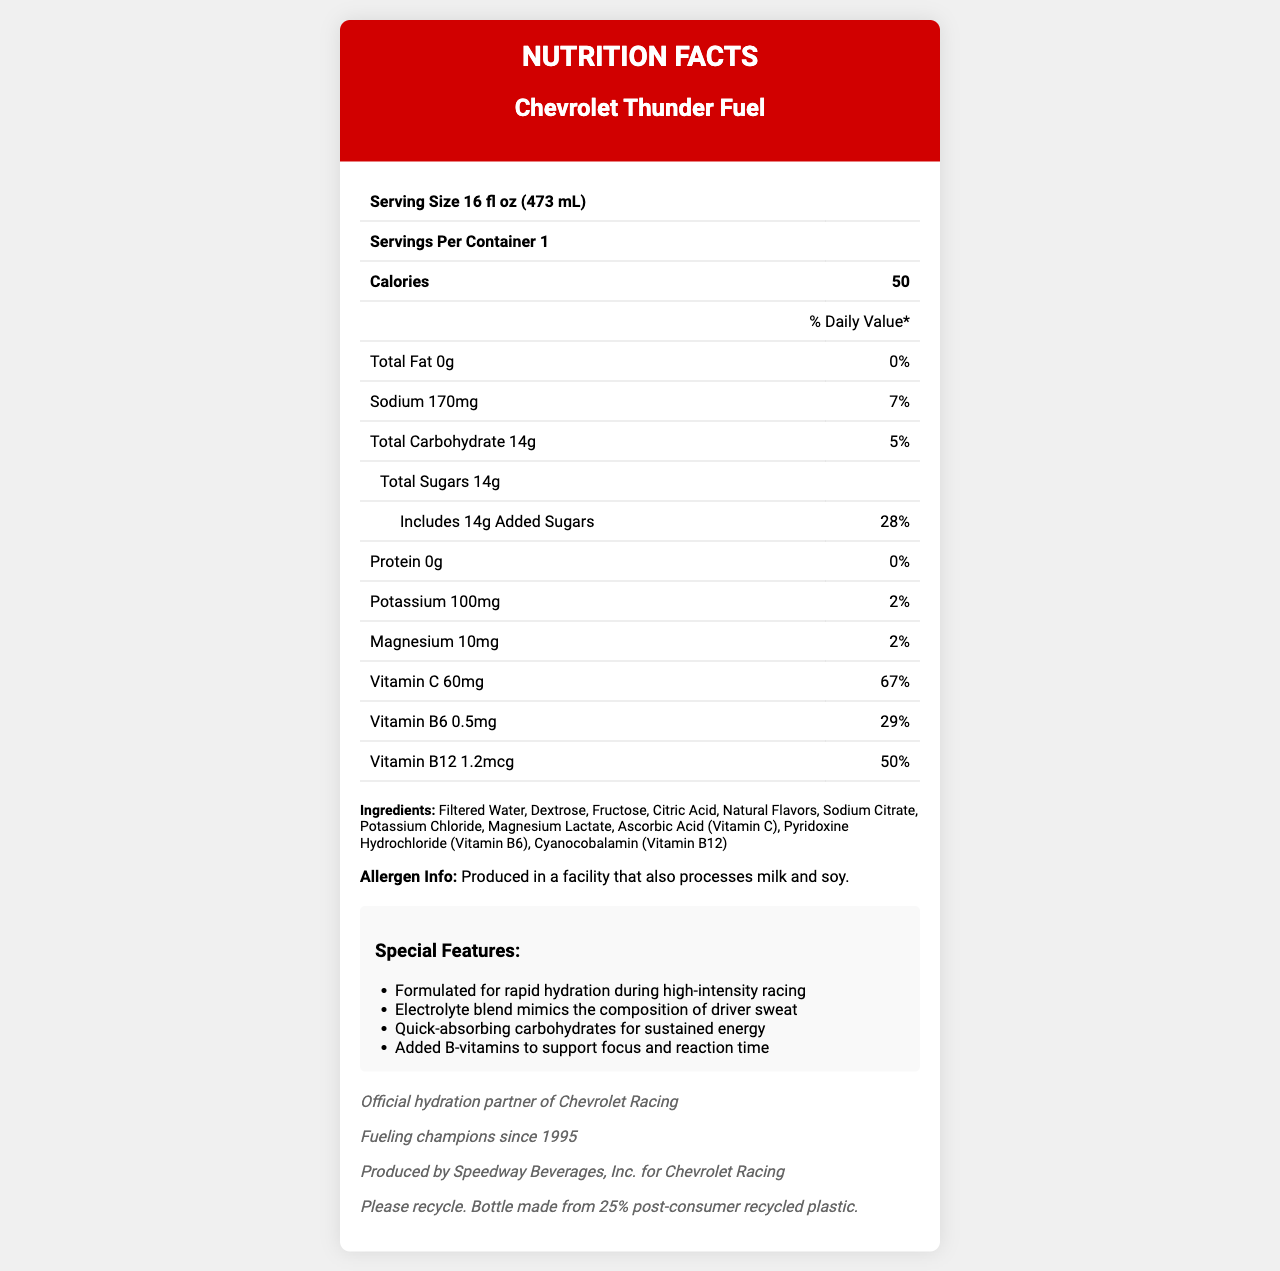What is the serving size of Chevrolet Thunder Fuel? The document states the serving size as "16 fl oz (473 mL)" under the Nutrition Facts section.
Answer: 16 fl oz (473 mL) How many calories are there per serving of Chevrolet Thunder Fuel? The Nutrition Facts section lists the calories per serving as 50.
Answer: 50 calories What is the amount of sodium in one serving? The Nutrition Facts state that there are 170mg of sodium in one serving.
Answer: 170mg How much added sugar is in a serving of Chevrolet Thunder Fuel? The document indicates that the total and added sugars are both 14g per serving.
Answer: 14g What percentage of the daily value of Vitamin C does a serving of Chevrolet Thunder Fuel provide? The Nutrition Facts section lists Vitamin C as providing 67% of the daily value.
Answer: 67% Which ingredient is not listed in the ingredients of Chevrolet Thunder Fuel? A. Potassium Chloride B. Sodium Citrate C. Sugar D. Filtered Water The listed ingredients include filtered water, sodium citrate, and potassium chloride, but not sugar mentioned separately.
Answer: C How does Chevrolet Thunder Fuel support focus and reaction time? A. Electrolytes B. B-vitamins C. Carbohydrates D. Protein The special features mention that added B-vitamins support focus and reaction time.
Answer: B Is Chevrolet Thunder Fuel suitable for someone with a milk allergy? The allergen info states it's produced in a facility that processes milk and soy, which may pose a risk for someone with a milk allergy.
Answer: No Summarize the main features and nutritional components of Chevrolet Thunder Fuel. The document provides detailed nutritional information, highlights the product's special features aimed at NASCAR drivers, lists the ingredients, and includes a brand statement emphasizing its use in racing contexts.
Answer: Chevrolet Thunder Fuel is a sports hydration beverage with a serving size of 16 fl oz, containing 50 calories, 14g of carbohydrates (all sugars), 170mg of sodium, 100mg of potassium, and various vitamins such as C, B6, and B12. It is designed for rapid hydration during high-intensity racing and supports focus and reaction time with B-vitamins. The beverage is produced by Speedway Beverages, Inc. for Chevrolet Racing and comes with a citrus blast flavor. What is the stated marketing claim for Chevrolet Thunder Fuel? The document specifies this as the marketing claim in the brand info section.
Answer: Fueling champions since 1995 Who produces Chevrolet Thunder Fuel? The manufacturer information mentions that Speedway Beverages, Inc. produces the beverage for Chevrolet Racing.
Answer: Speedway Beverages, Inc. What is the total carbohydrate content in one serving? The total carbohydrate content per serving is listed as 14g in the Nutrition Facts section.
Answer: 14g What is the suggested use of Chevrolet Thunder Fuel according to the document? The special features indicate that it is formulated for rapid hydration during high-intensity racing.
Answer: For rapid hydration during high-intensity racing Can we determine the exact price of Chevrolet Thunder Fuel from the document? The document does not provide any information about the price of Chevrolet Thunder Fuel.
Answer: Cannot be determined 